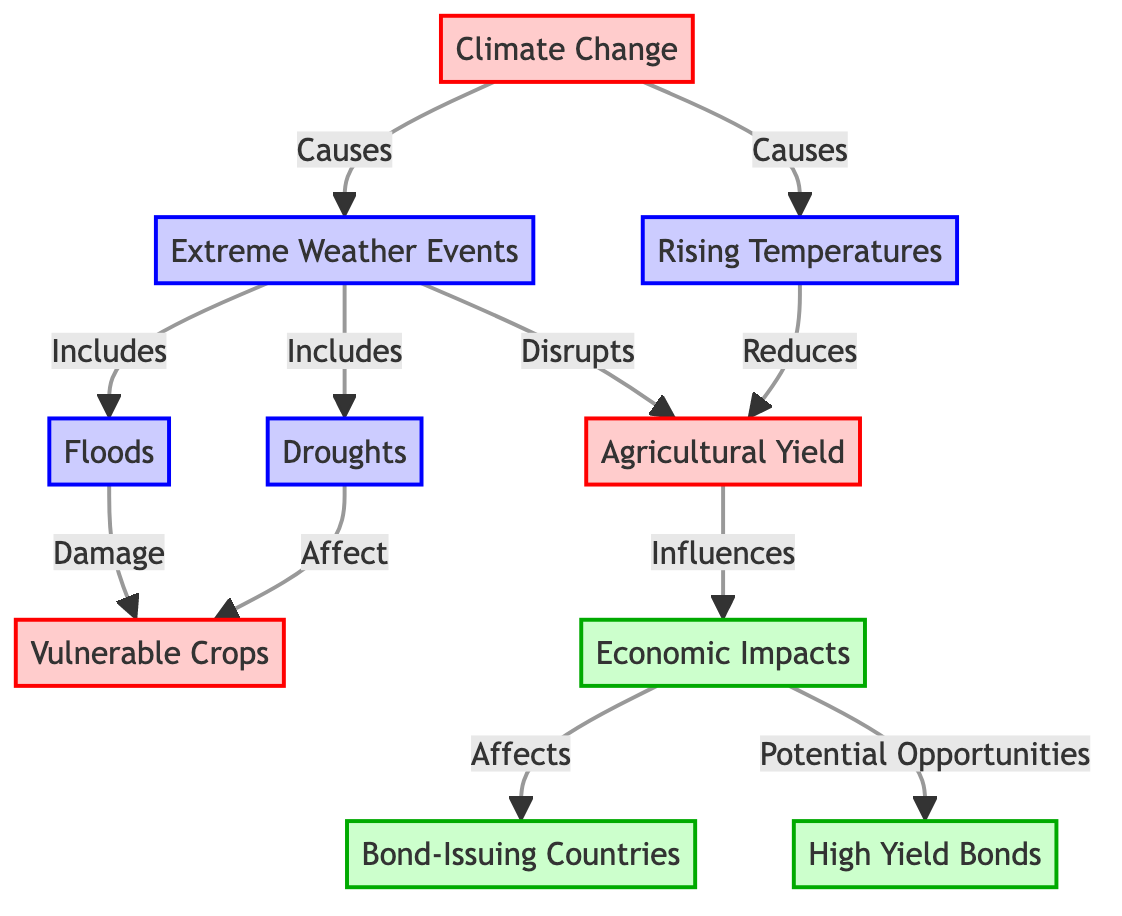What is one of the impacts of climate change on agricultural yield? The diagram indicates that climate change causes rising temperatures, which in turn reduces agricultural yield. Therefore, one specific impact of climate change on agricultural yield is the reduction caused by rising temperatures.
Answer: Reduction How many types of extreme weather events are identified in this diagram? The diagram highlights two types of extreme weather events: droughts and floods. By counting these listed events, we find there are 2 types of extreme weather events identified in the diagram.
Answer: 2 Which node affects vulnerable crops according to the diagram? The diagram demonstrates that droughts and floods specifically affect vulnerable crops. Therefore, droughts are one of the nodes that affect vulnerable crops in the visual information.
Answer: Droughts What economic aspect does agricultural yield influence? According to the diagram, agricultural yield influences economic impacts. This relationship indicates that changes in agricultural yield have direct implications on economic factors within bond-issuing countries.
Answer: Economic Impacts How do economic impacts relate to bond-issuing countries? The diagram shows that economic impacts affect bond-issuing countries, suggesting that changes in the economy due to agricultural yield will have implications for these countries’ bond markets. Specifically, economic impacts influence the economic health of bond-issuing countries.
Answer: Affects What are the potential opportunities linked to economic impacts? The diagram illustrates that economic impacts lead to potential opportunities in high yield bonds. This suggests that as agricultural yield changes impact the economy, it could also create opportunities in the high yield bond market.
Answer: High Yield Bonds How many specific weather events are described in the diagram? The diagram lists four specific weather events under extreme weather: droughts, floods, rising temperatures, and extreme weather events themselves. Therefore, the total number of specific weather events described is 4.
Answer: 4 What does rising temperatures do to agricultural yield? The diagram states that rising temperatures reduce agricultural yield. This indicates a direct negative effect that rising temperatures have on the overall agricultural production in the affected areas.
Answer: Reduces Which element causes both floods and droughts? The diagram indicates that extreme weather events include floods and droughts. Hence, extreme weather is the element that causes both types of events.
Answer: Extreme Weather 